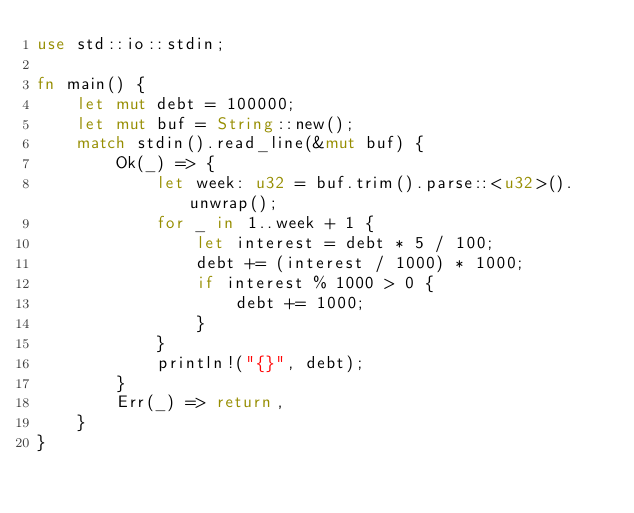<code> <loc_0><loc_0><loc_500><loc_500><_Rust_>use std::io::stdin;

fn main() {
    let mut debt = 100000;
    let mut buf = String::new();
    match stdin().read_line(&mut buf) {
        Ok(_) => {
            let week: u32 = buf.trim().parse::<u32>().unwrap();
            for _ in 1..week + 1 {
                let interest = debt * 5 / 100;
                debt += (interest / 1000) * 1000;
                if interest % 1000 > 0 {
                    debt += 1000;
                }
            }
            println!("{}", debt);
        }
        Err(_) => return,
    }
}

</code> 